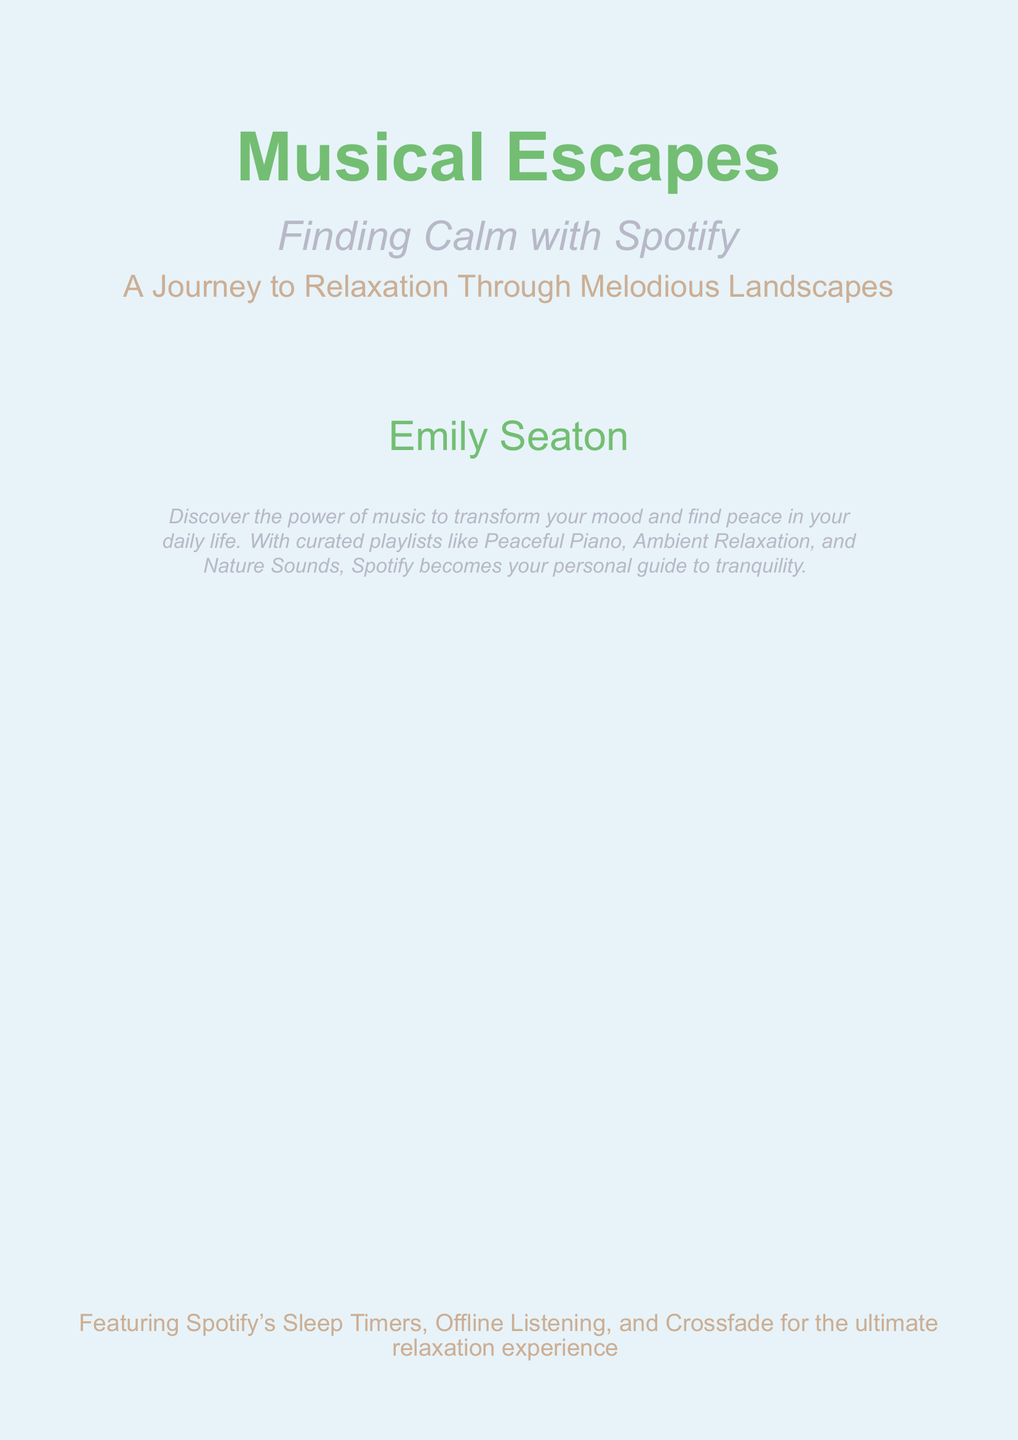What is the title of the book? The title is prominently displayed at the top of the cover, which focuses on the subject of the book.
Answer: Musical Escapes What is the subtitle of the book? The subtitle is located directly beneath the title and adds context to the main theme of the book.
Answer: Finding Calm with Spotify Who is the author of the book? The author's name is centered towards the bottom of the cover, indicating authorship.
Answer: Emily Seaton What type of music does the book mention for relaxation? The document lists specific types of playlists that can be used to achieve relaxation through music, making it clear what genres are recommended.
Answer: Peaceful Piano, Ambient Relaxation, Nature Sounds What is the main theme of the book? The theme is encapsulated in the descriptive phrase that summarizes the purpose of the book.
Answer: A Journey to Relaxation Through Melodious Landscapes What color is the background of the cover? The background color is explicitly defined to set the tone of the book cover design.
Answer: Soft blue What features does the book highlight about Spotify? The document points out unique features of Spotify relevant to relaxation that enhance the listening experience.
Answer: Sleep Timers, Offline Listening, Crossfade What is indicated by the picturesque landscape? The landscape illustration is intended to represent a calming setting that aligns with the book's theme.
Answer: Calmness What mood does the color scheme convey? The color choices are described to create a specific emotional response that supports the book's relaxation theme.
Answer: Tranquility 